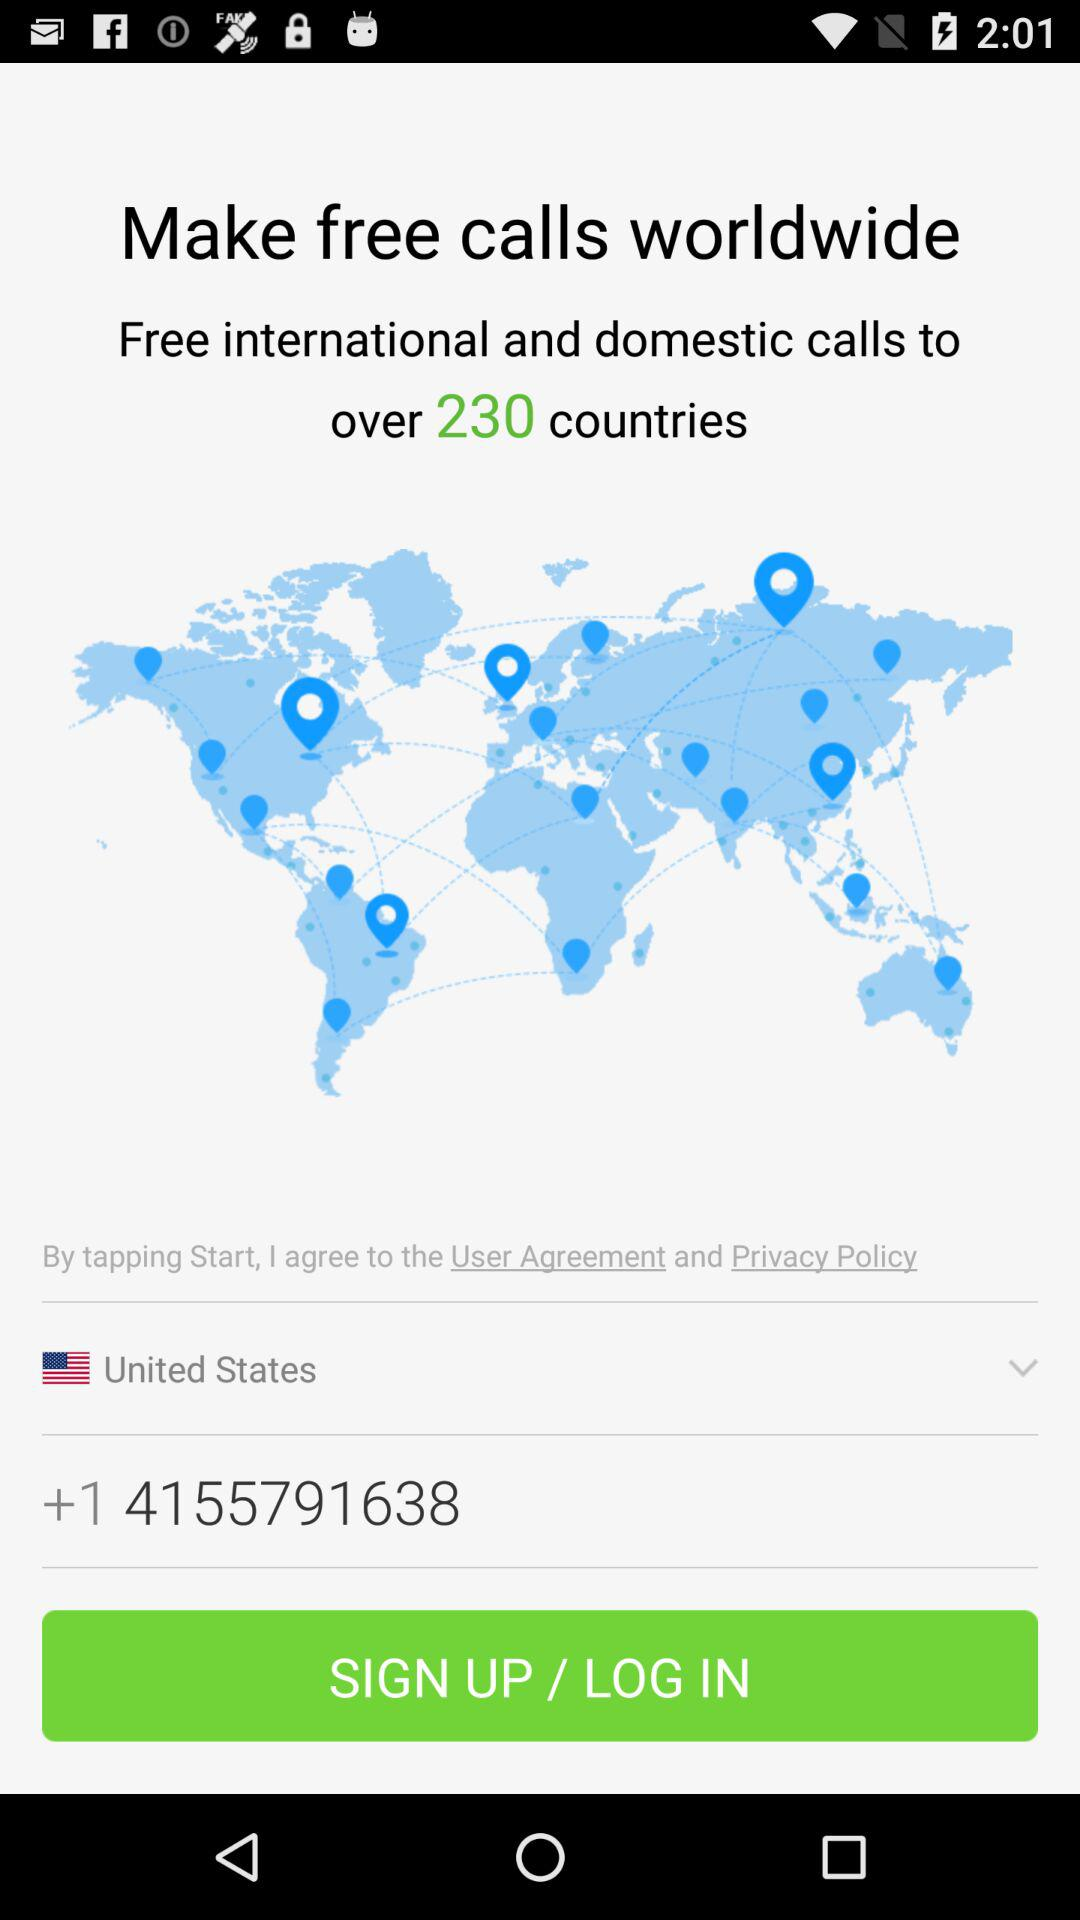How many countries can I call for free? You can call over 230 countries for free. 